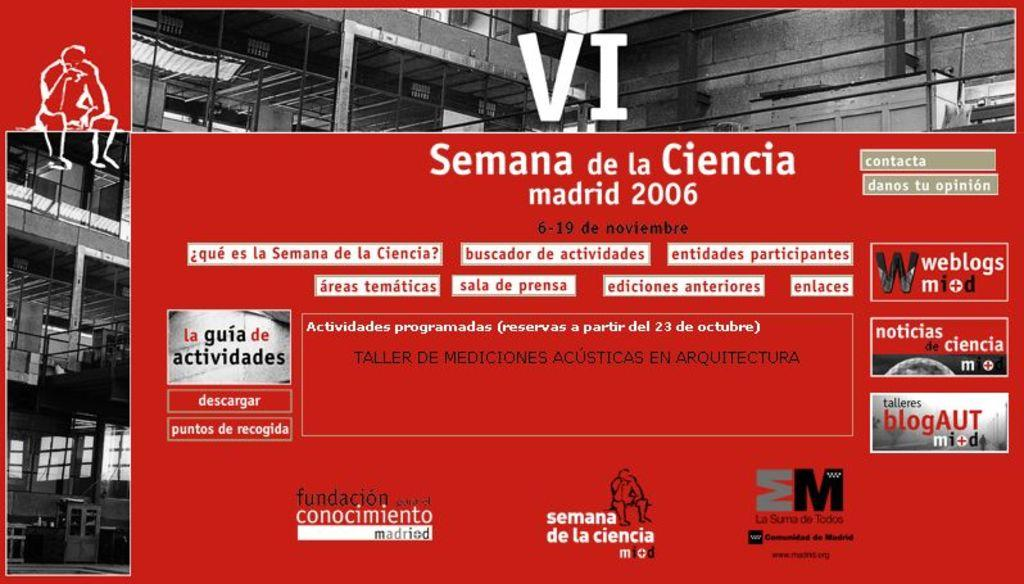<image>
Relay a brief, clear account of the picture shown. An ad for an event happening in Madrid in November of 2006 has a large "VI" at the top. 